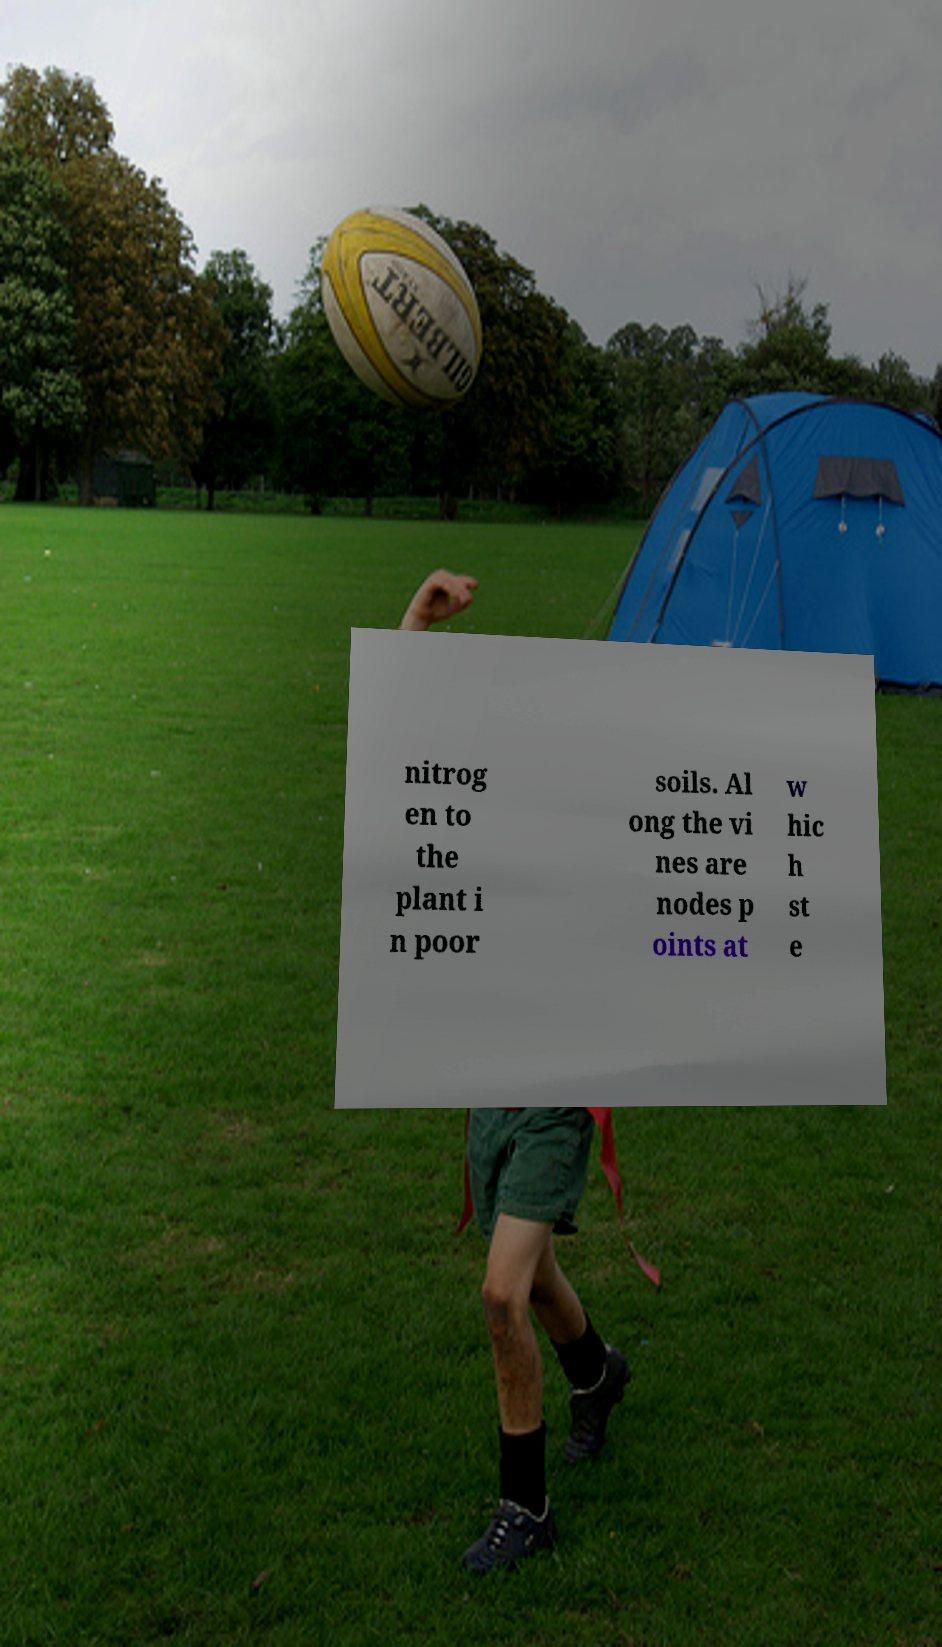There's text embedded in this image that I need extracted. Can you transcribe it verbatim? nitrog en to the plant i n poor soils. Al ong the vi nes are nodes p oints at w hic h st e 